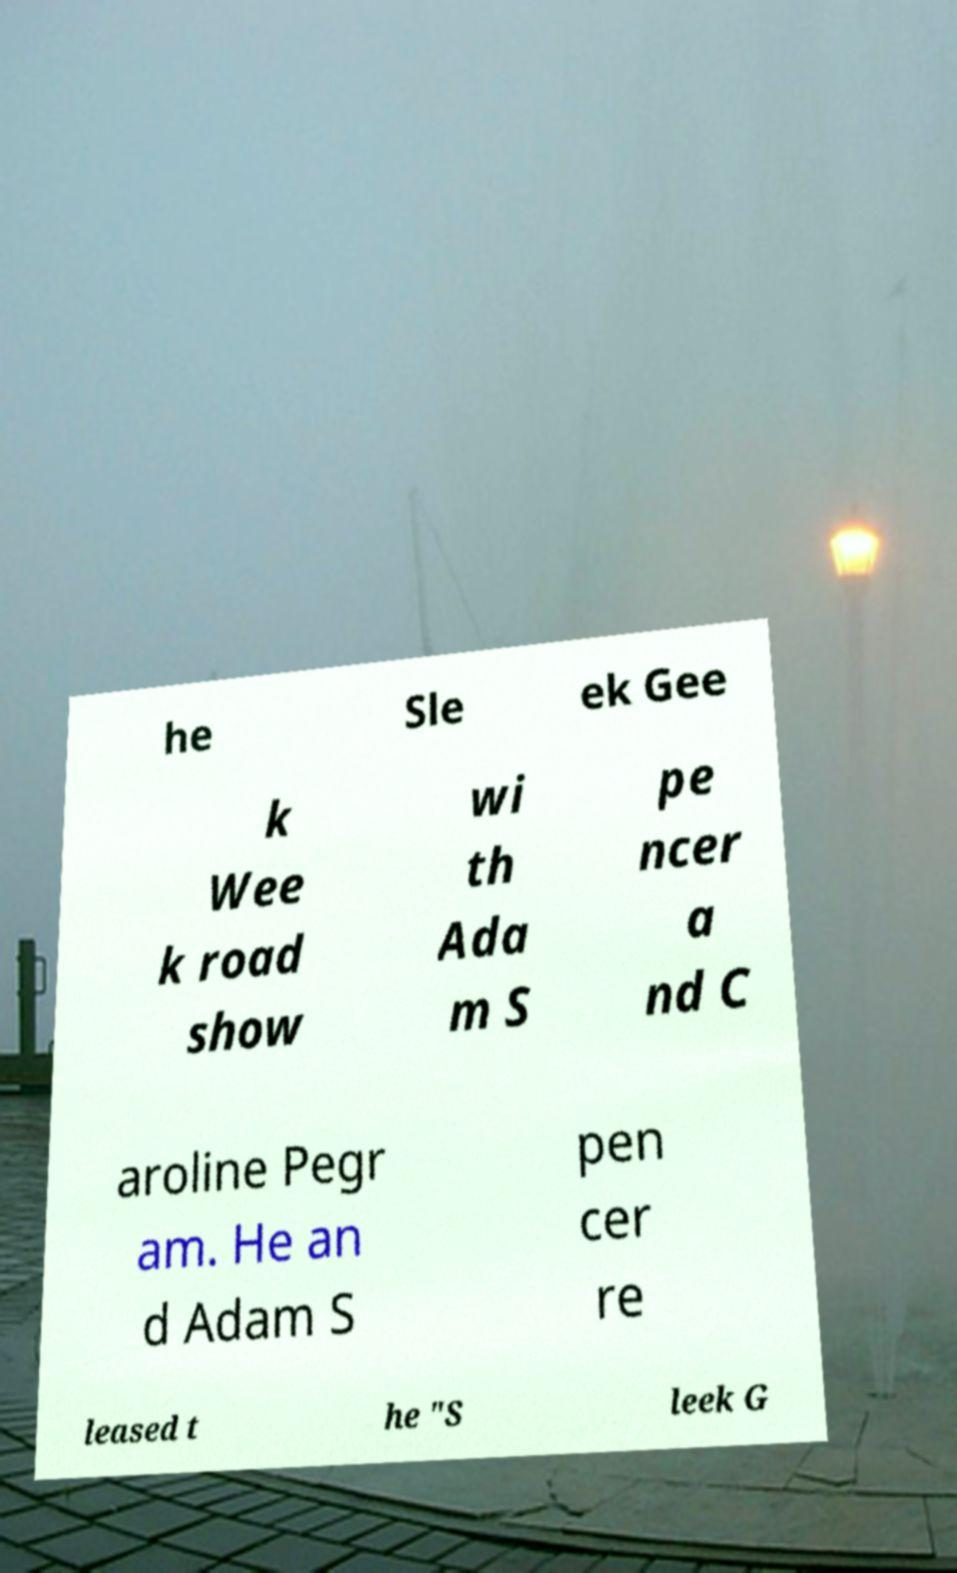Can you accurately transcribe the text from the provided image for me? he Sle ek Gee k Wee k road show wi th Ada m S pe ncer a nd C aroline Pegr am. He an d Adam S pen cer re leased t he "S leek G 